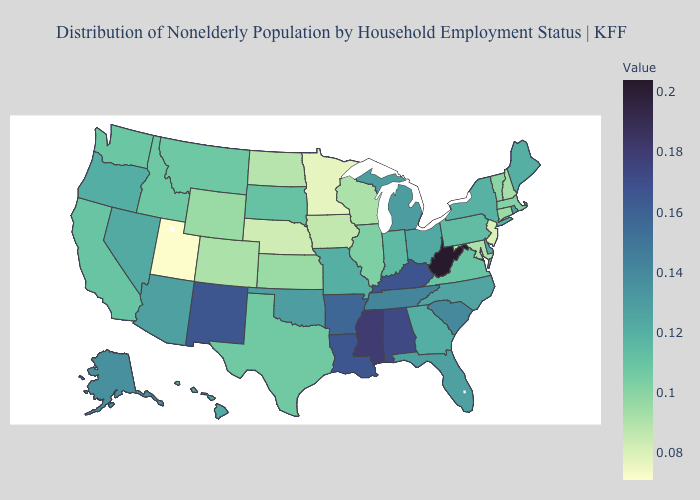Does Massachusetts have the lowest value in the Northeast?
Answer briefly. No. Which states have the lowest value in the Northeast?
Keep it brief. New Jersey. Does Texas have a higher value than Alabama?
Concise answer only. No. Which states hav the highest value in the South?
Short answer required. West Virginia. Does New Hampshire have a higher value than Minnesota?
Answer briefly. Yes. Which states have the highest value in the USA?
Short answer required. West Virginia. Does the map have missing data?
Answer briefly. No. 